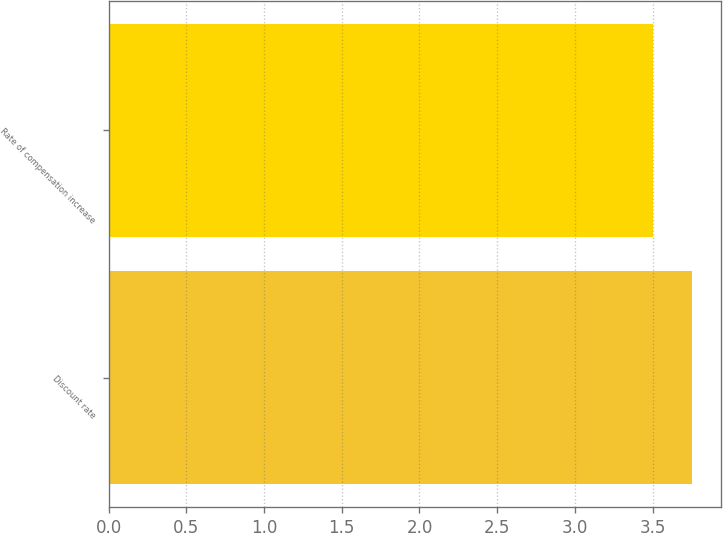Convert chart to OTSL. <chart><loc_0><loc_0><loc_500><loc_500><bar_chart><fcel>Discount rate<fcel>Rate of compensation increase<nl><fcel>3.75<fcel>3.5<nl></chart> 